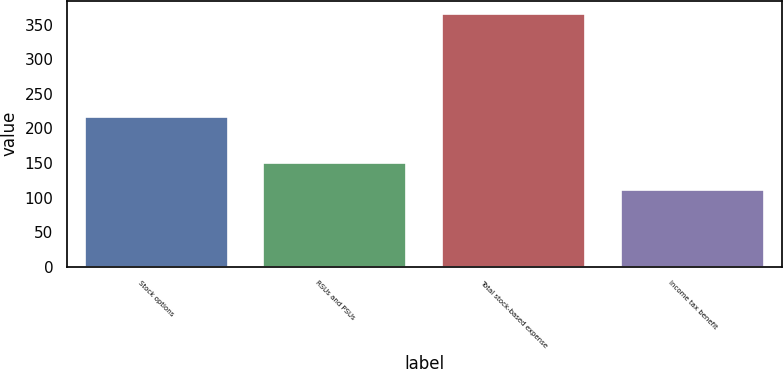Convert chart. <chart><loc_0><loc_0><loc_500><loc_500><bar_chart><fcel>Stock options<fcel>RSUs and PSUs<fcel>Total stock-based expense<fcel>Income tax benefit<nl><fcel>216<fcel>150<fcel>366<fcel>111<nl></chart> 